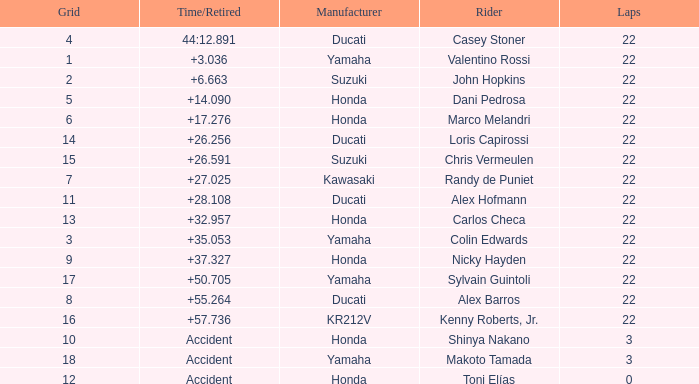What is the average grid for competitors who had more than 22 laps and time/retired of +17.276? None. 